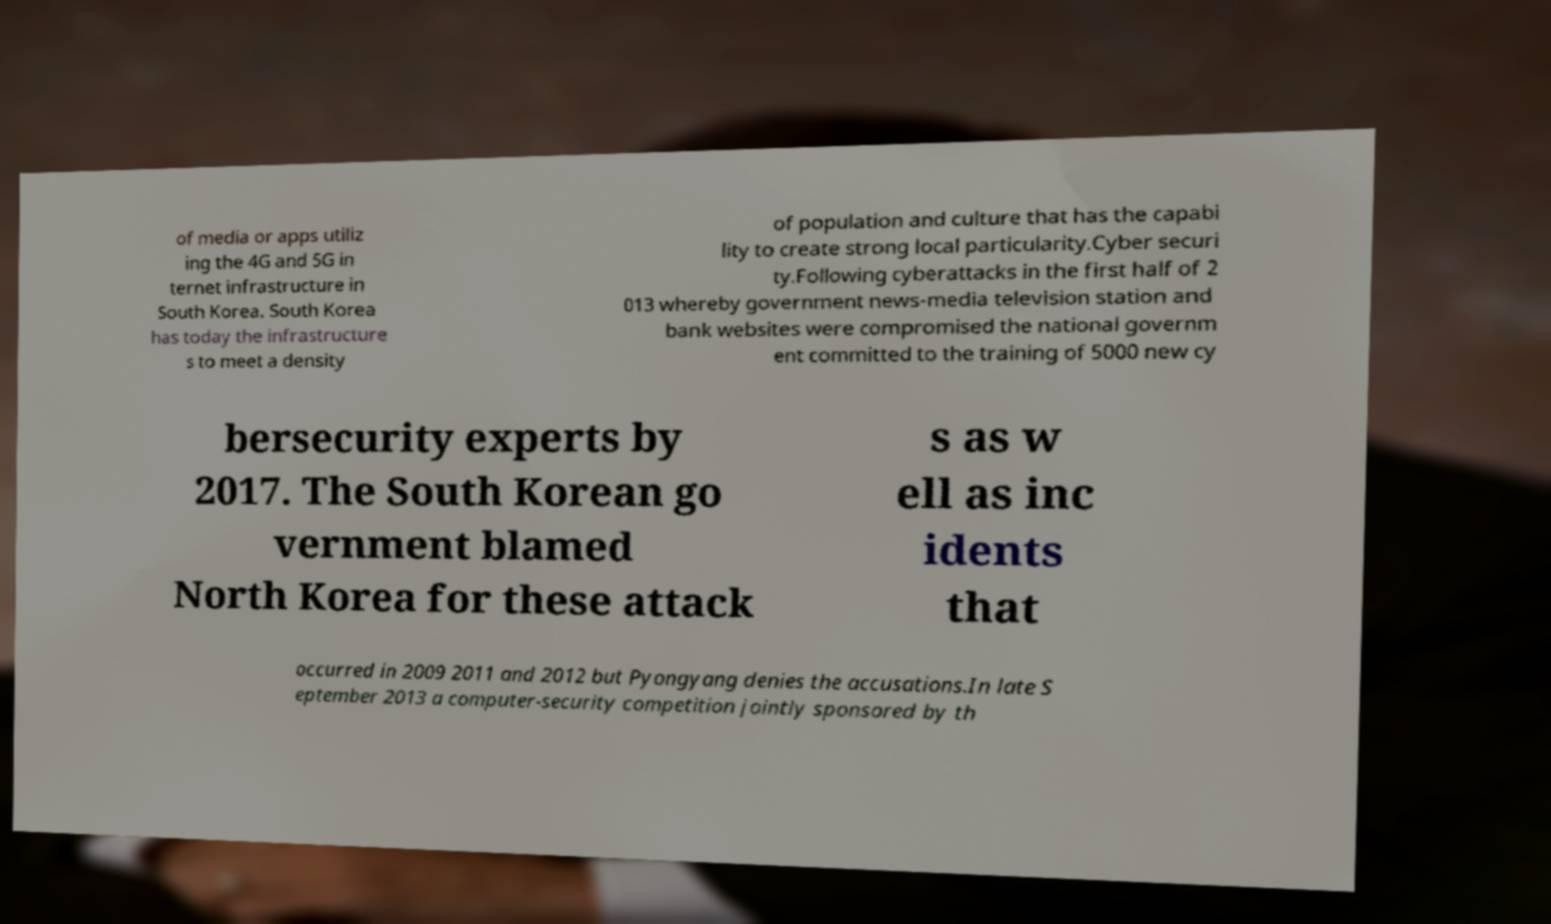Can you accurately transcribe the text from the provided image for me? of media or apps utiliz ing the 4G and 5G in ternet infrastructure in South Korea. South Korea has today the infrastructure s to meet a density of population and culture that has the capabi lity to create strong local particularity.Cyber securi ty.Following cyberattacks in the first half of 2 013 whereby government news-media television station and bank websites were compromised the national governm ent committed to the training of 5000 new cy bersecurity experts by 2017. The South Korean go vernment blamed North Korea for these attack s as w ell as inc idents that occurred in 2009 2011 and 2012 but Pyongyang denies the accusations.In late S eptember 2013 a computer-security competition jointly sponsored by th 